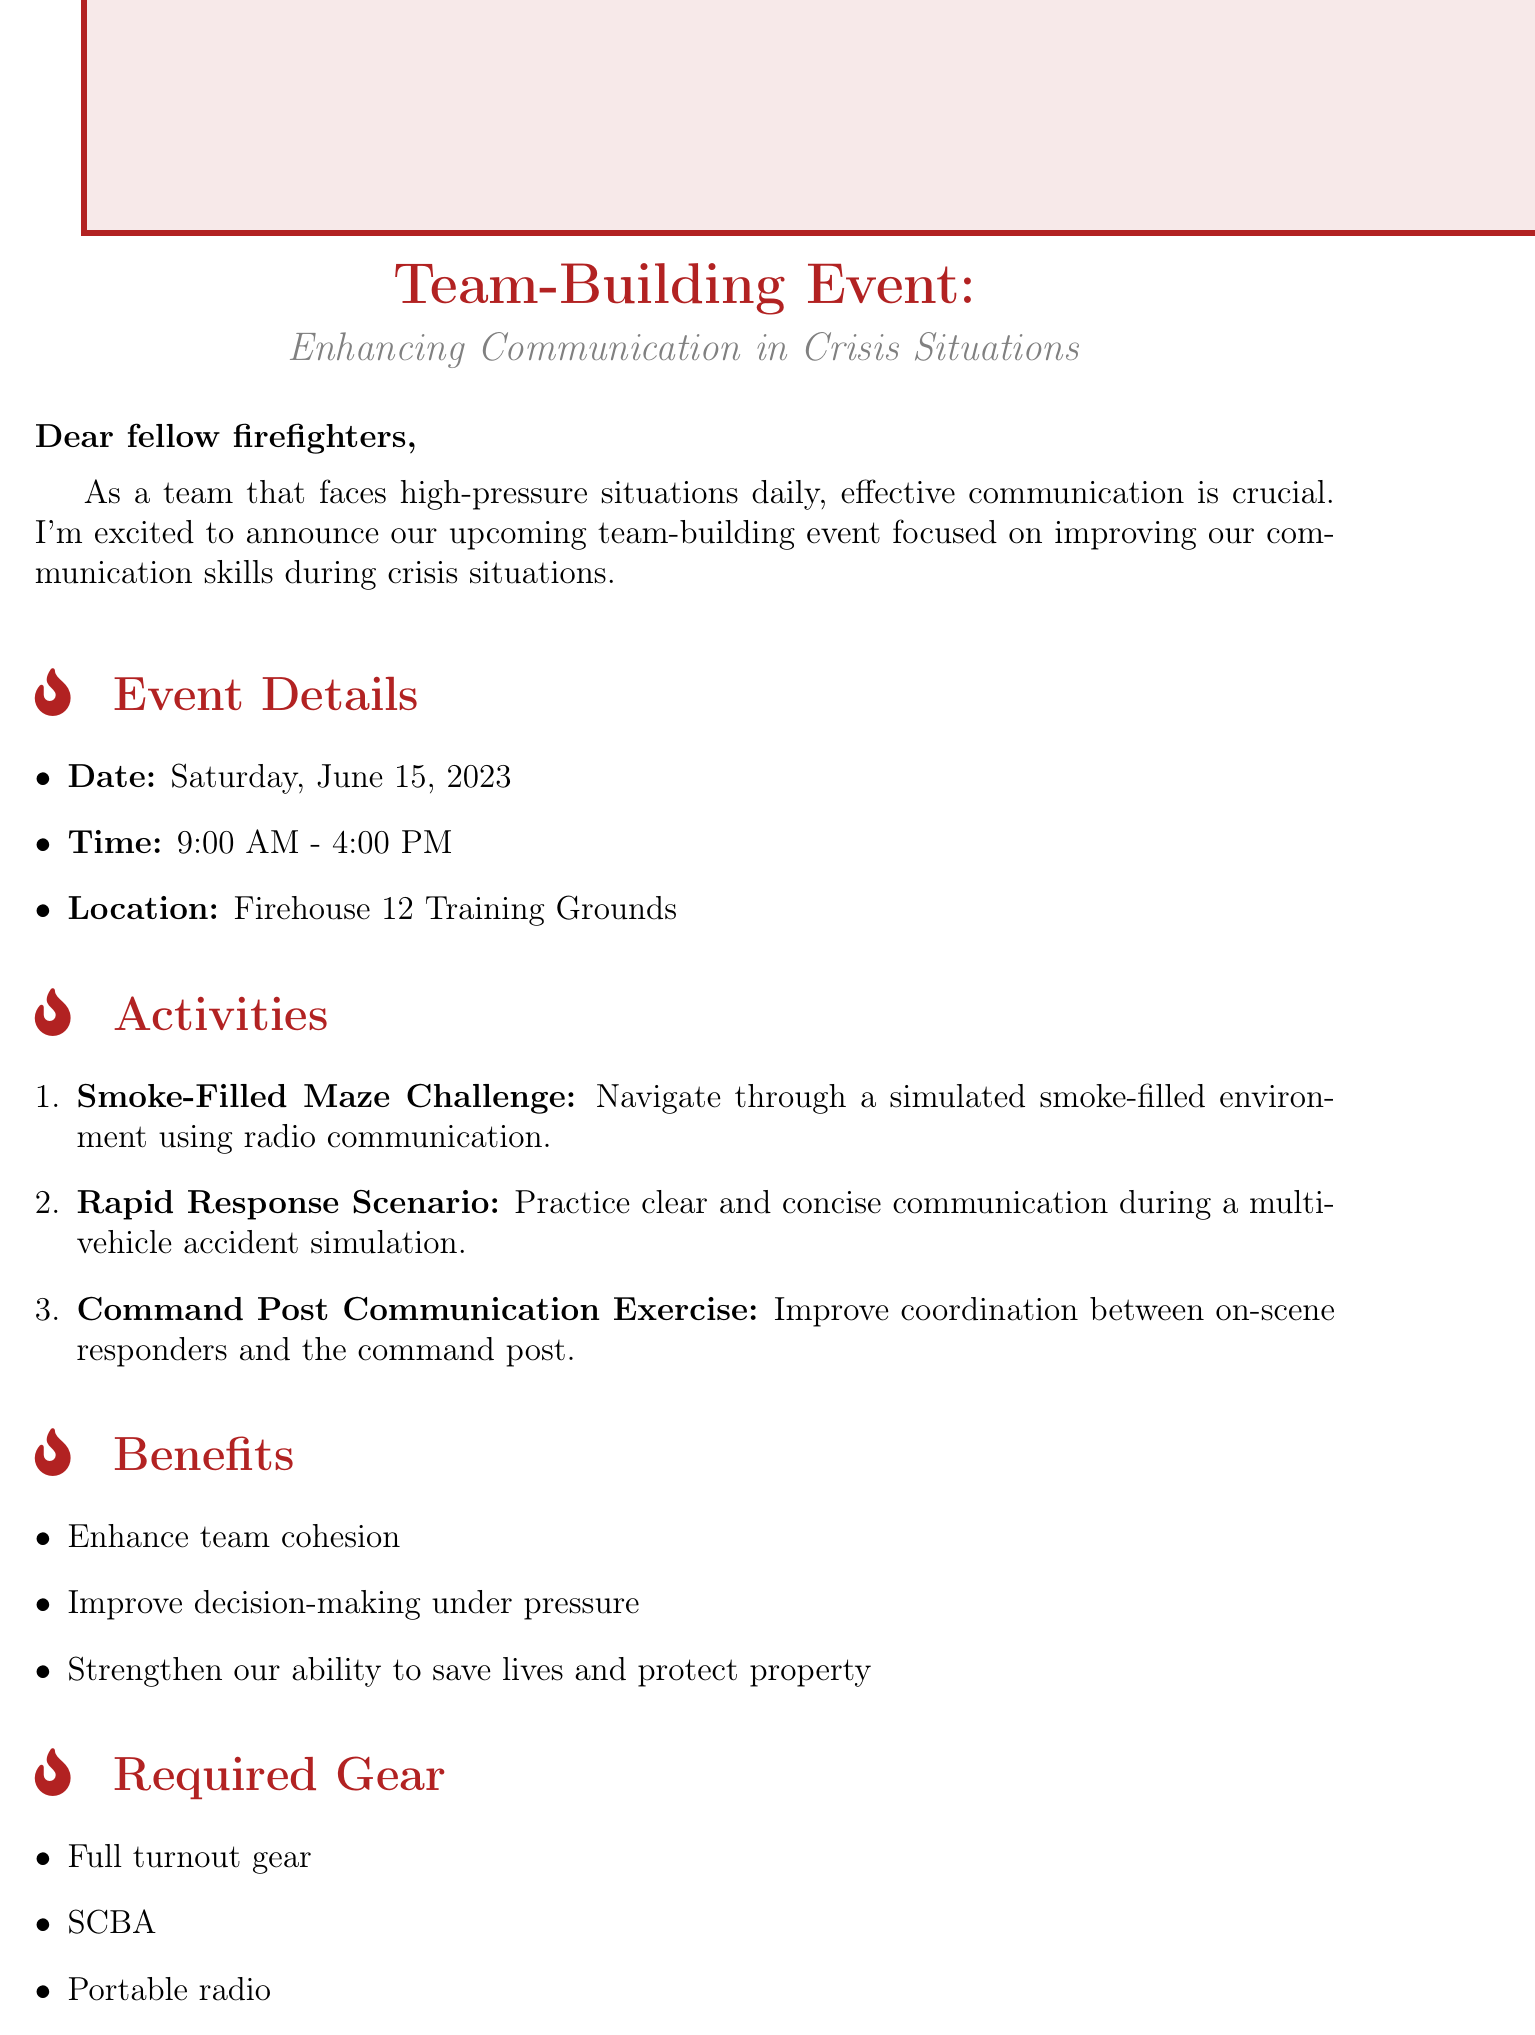what is the date of the event? The date of the event is clearly stated in the event details section.
Answer: Saturday, June 15, 2023 what time does the event start? The starting time of the event is specified in the event details section.
Answer: 9:00 AM where will the event take place? The location of the event is mentioned in the event details.
Answer: Firehouse 12 Training Grounds what is one of the activities planned for the event? An activity from the activities section illustrates practical exercises to improve communication.
Answer: Smoke-Filled Maze Challenge by what date should I RSVP? The RSVP deadline is specified in the RSVP instructions section.
Answer: June 1, 2023 who should I contact to RSVP? The email instructions indicate the person to contact for RSVPs.
Answer: Captain Sarah Johnson what is required gear for participation? The required gear list outlines what participants need to bring for the event.
Answer: Full turnout gear how will the event benefit the team? The benefits section lists several improvements expected from the event.
Answer: Enhance team cohesion what type of communication will be practiced? The activities mentioned indicate the focus on crisis communication methods.
Answer: Radio communication how long is the event scheduled to last? The duration of the event can be calculated based on the start and end times provided.
Answer: 7 hours 